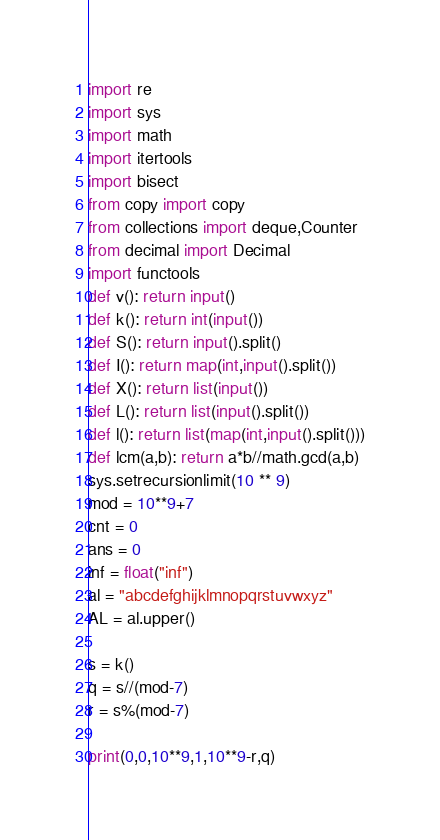Convert code to text. <code><loc_0><loc_0><loc_500><loc_500><_Python_>import re
import sys
import math
import itertools
import bisect
from copy import copy
from collections import deque,Counter
from decimal import Decimal
import functools
def v(): return input()
def k(): return int(input())
def S(): return input().split()
def I(): return map(int,input().split())
def X(): return list(input())
def L(): return list(input().split())
def l(): return list(map(int,input().split()))
def lcm(a,b): return a*b//math.gcd(a,b)
sys.setrecursionlimit(10 ** 9)
mod = 10**9+7
cnt = 0
ans = 0
inf = float("inf")
al = "abcdefghijklmnopqrstuvwxyz"
AL = al.upper()

s = k()
q = s//(mod-7)
r = s%(mod-7)

print(0,0,10**9,1,10**9-r,q)</code> 